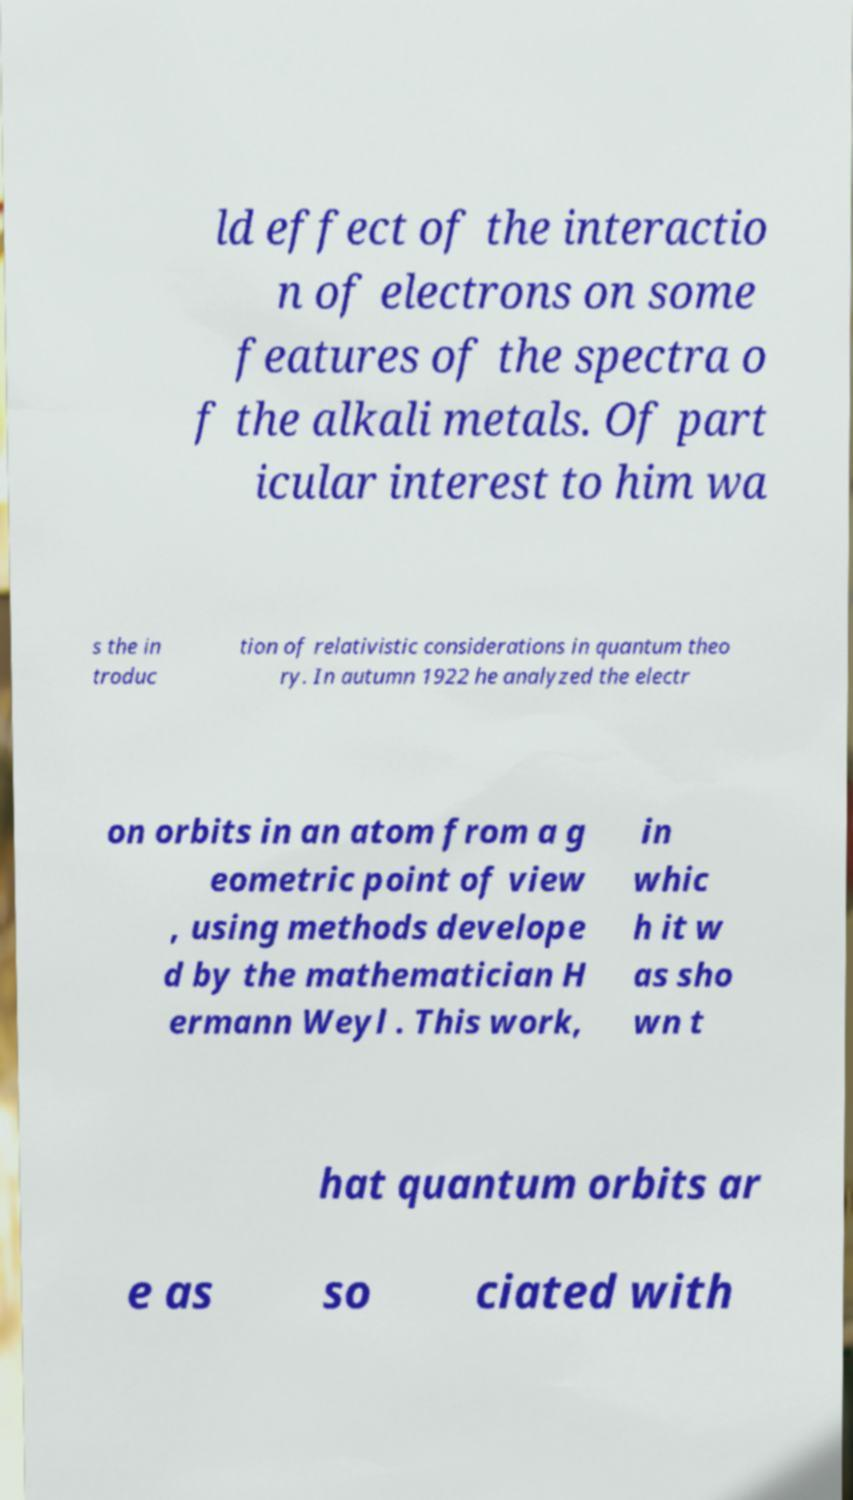Could you extract and type out the text from this image? ld effect of the interactio n of electrons on some features of the spectra o f the alkali metals. Of part icular interest to him wa s the in troduc tion of relativistic considerations in quantum theo ry. In autumn 1922 he analyzed the electr on orbits in an atom from a g eometric point of view , using methods develope d by the mathematician H ermann Weyl . This work, in whic h it w as sho wn t hat quantum orbits ar e as so ciated with 